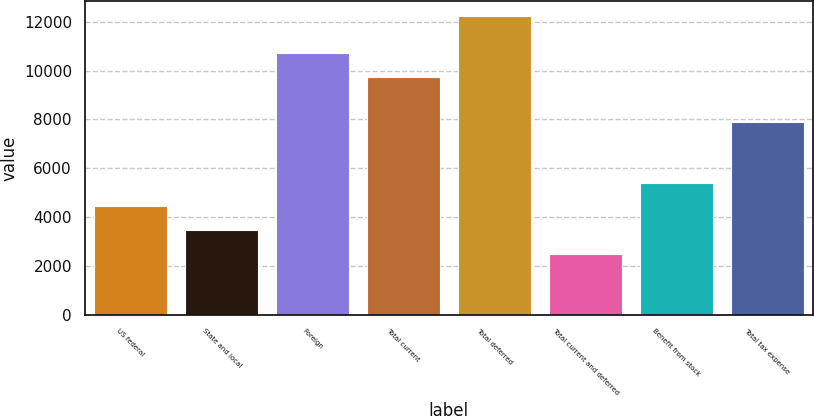<chart> <loc_0><loc_0><loc_500><loc_500><bar_chart><fcel>US federal<fcel>State and local<fcel>Foreign<fcel>Total current<fcel>Total deferred<fcel>Total current and deferred<fcel>Benefit from stock<fcel>Total tax expense<nl><fcel>4432<fcel>3458.5<fcel>10708.5<fcel>9735<fcel>12220<fcel>2485<fcel>5405.5<fcel>7875<nl></chart> 